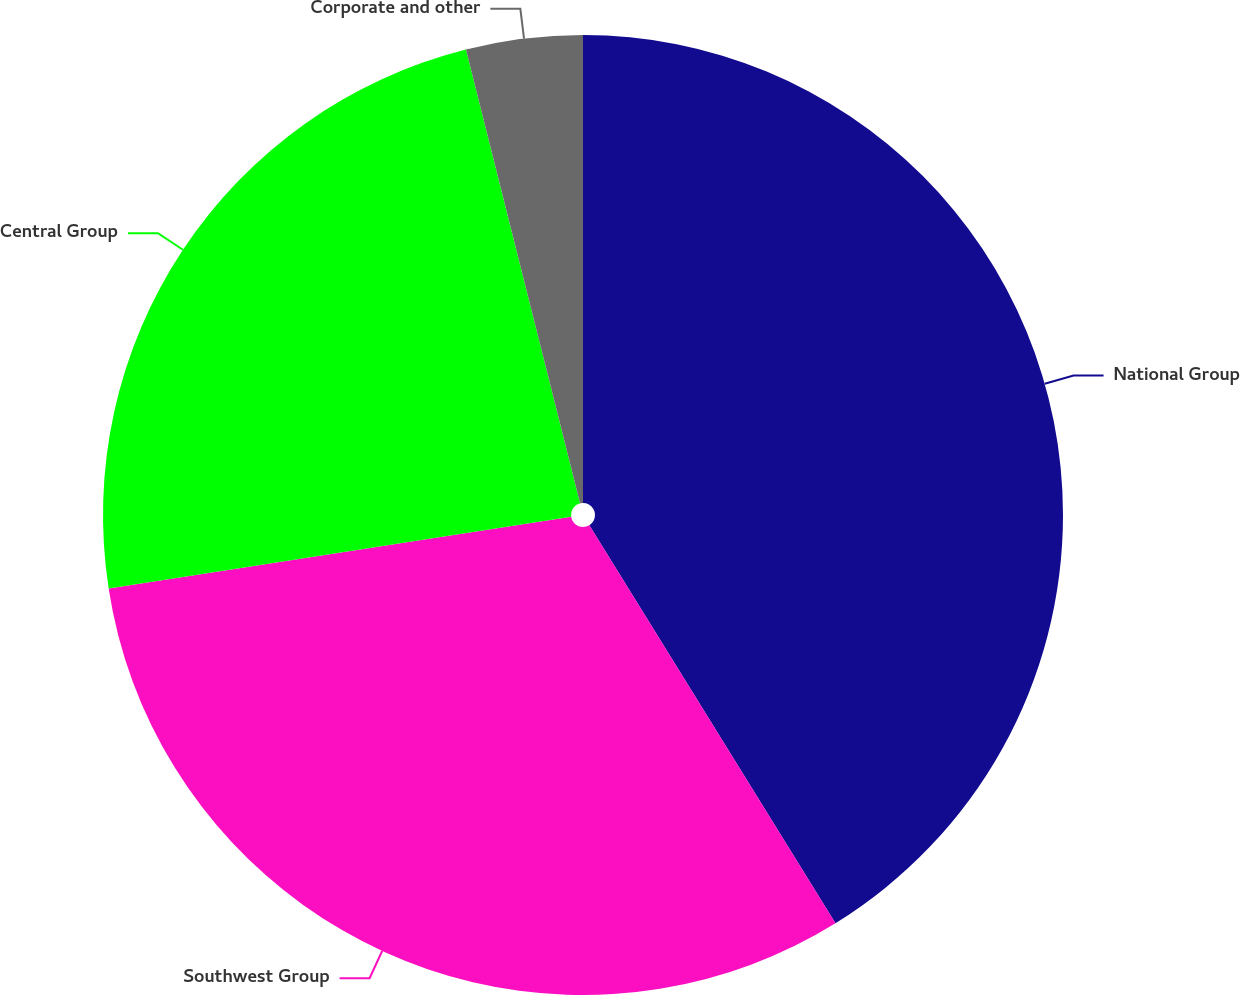Convert chart to OTSL. <chart><loc_0><loc_0><loc_500><loc_500><pie_chart><fcel>National Group<fcel>Southwest Group<fcel>Central Group<fcel>Corporate and other<nl><fcel>41.18%<fcel>31.37%<fcel>23.52%<fcel>3.92%<nl></chart> 